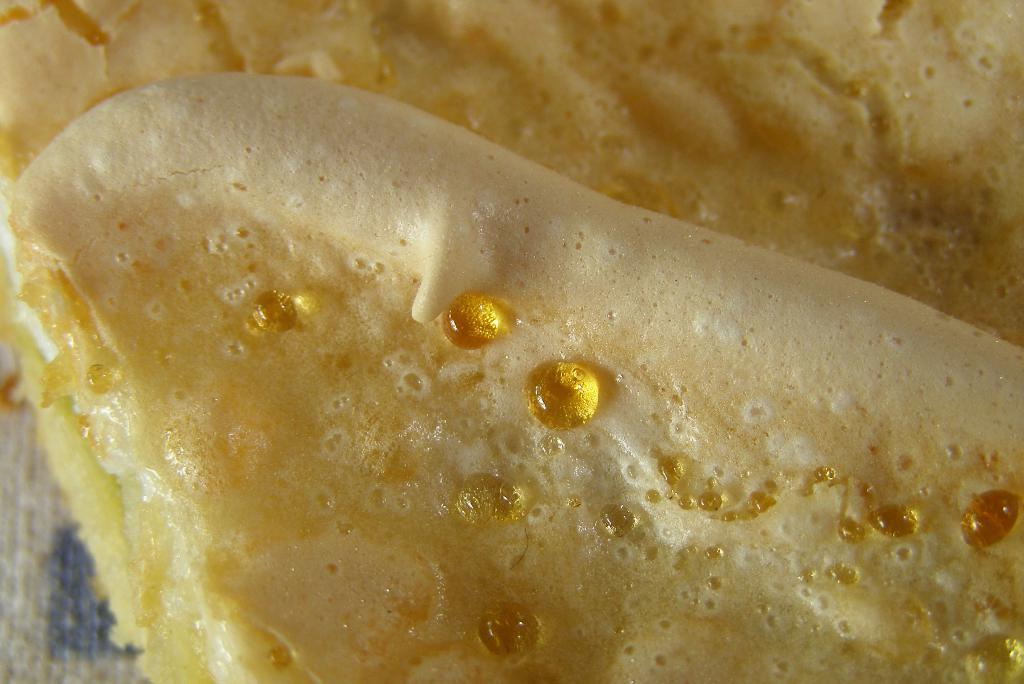What is on the table in the image? There is a bread on the table in the image. Can you describe the setting of the image? The image may have been taken in a room. How many cats are visible in the image? There are no cats present in the image. What type of soda is being served in the image? There is no soda present in the image. 